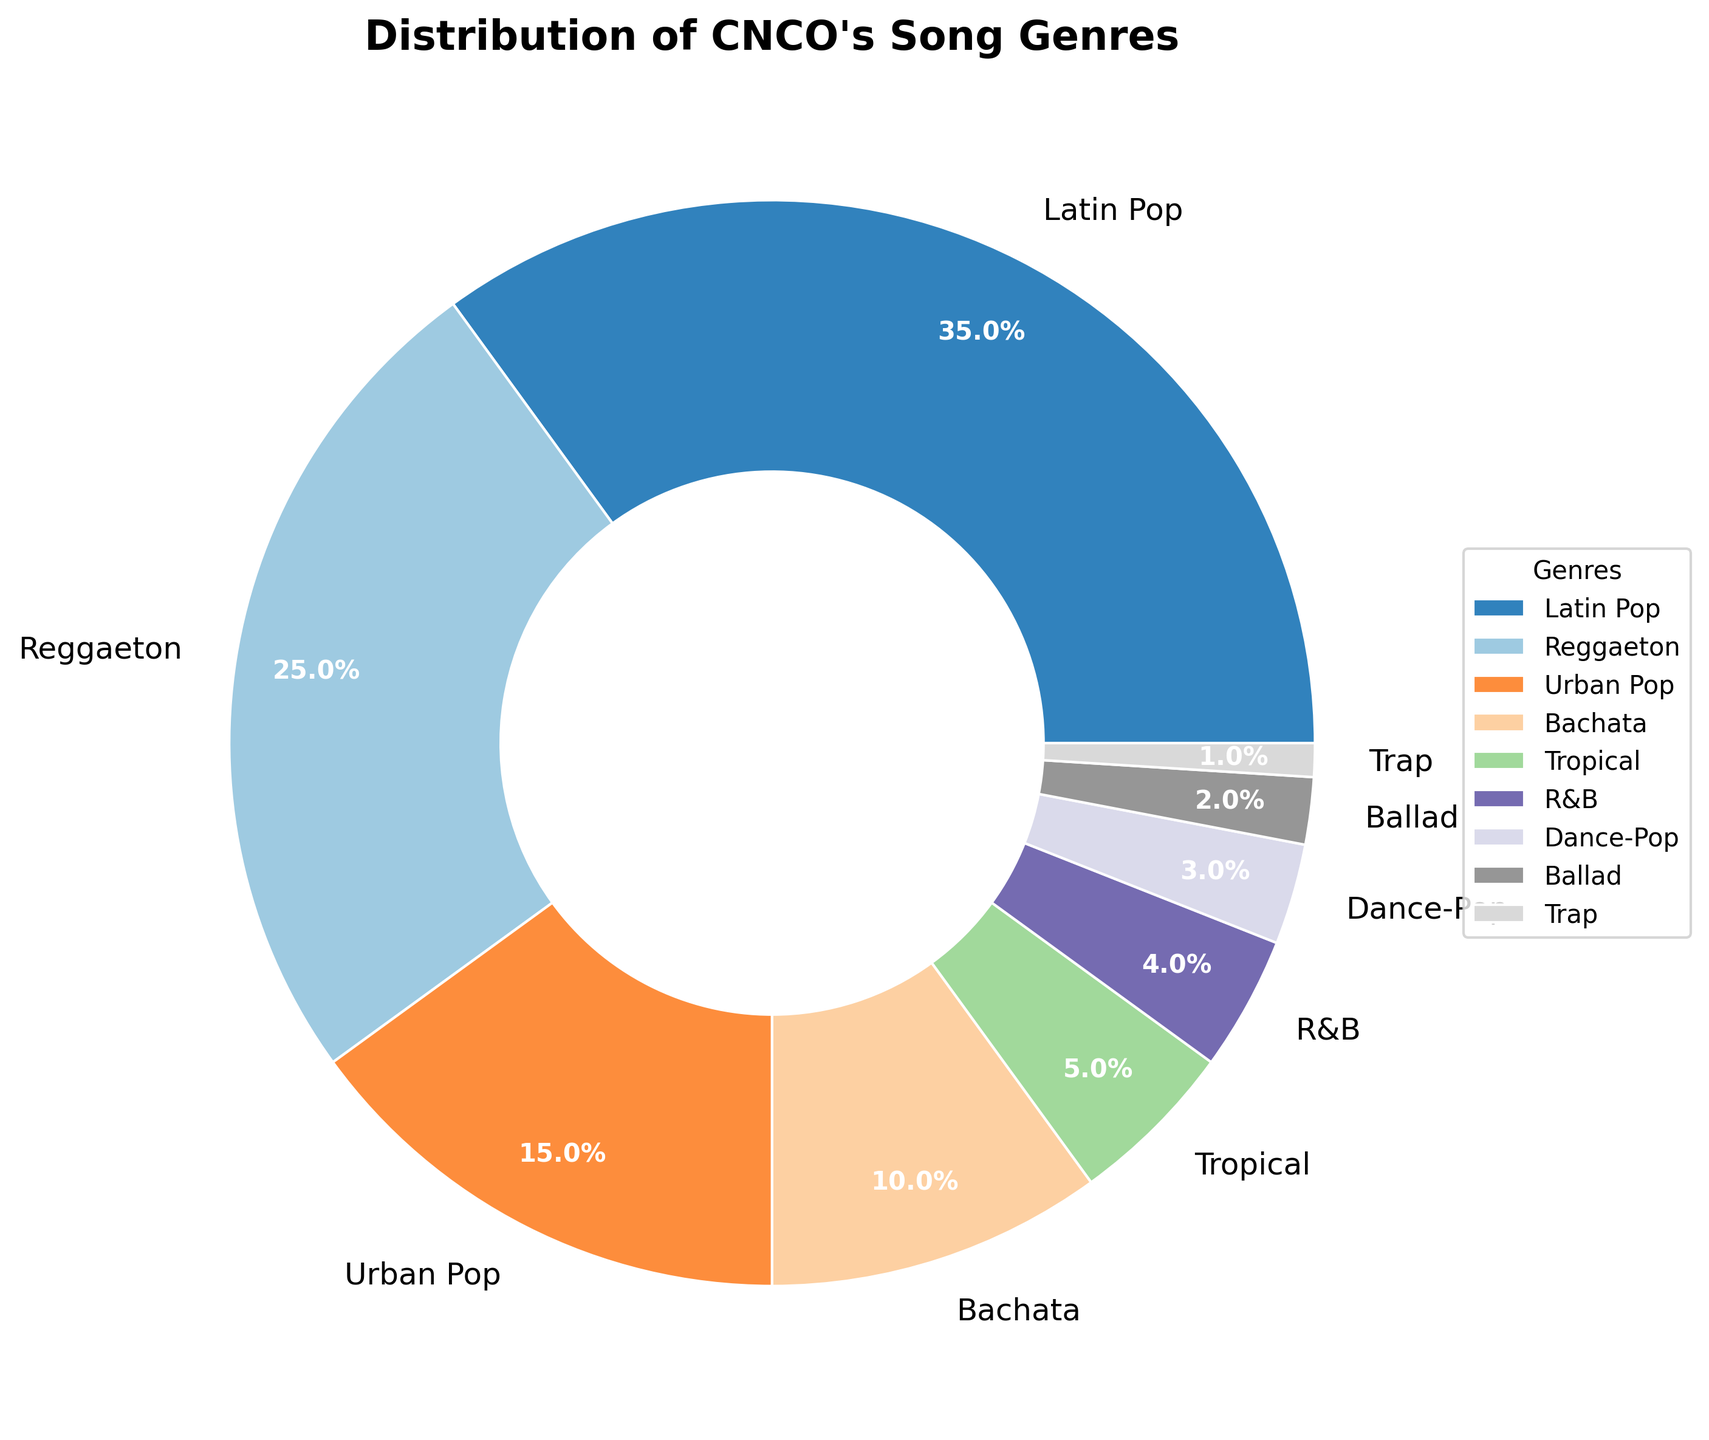Which genre has the highest percentage in CNCO's discography? By looking at the pie chart, find the genre with the largest slice. The genre with the highest percentage is Latin Pop at 35%.
Answer: Latin Pop Which genres have a smaller percentage than Urban Pop? Identify the percentage for Urban Pop, which is 15%. Then, compare this to the other genres. The genres with smaller percentages are Bachata (10%), Tropical (5%), R&B (4%), Dance-Pop (3%), Ballad (2%), and Trap (1%).
Answer: Bachata, Tropical, R&B, Dance-Pop, Ballad, Trap How do the percentages of Reggaeton and Latin Pop compare? Find the percentages for Reggaeton and Latin Pop, which are 25% and 35% respectively. Latin Pop's percentage is greater than Reggaeton's by 10 percentage points.
Answer: Latin Pop has 10% more than Reggaeton What is the combined percentage of genres that are less than or equal to 10%? Add the percentages of genres that are ≤10%: Bachata (10%) + Tropical (5%) + R&B (4%) + Dance-Pop (3%) + Ballad (2%) + Trap (1%) = 25%.
Answer: 25% What percentage of CNCO's songs are either Urban Pop or Dance-Pop? Add the percentages for Urban Pop (15%) and Dance-Pop (3%): 15% + 3% = 18%.
Answer: 18% Which genre represents the smallest percentage of CNCO's discography? Identify the genre with the smallest slice in the pie chart, which is Trap at 1%.
Answer: Trap Is the percentage of Bachata songs greater or less than the percentage of Tropical songs? Compare the percentages: Bachata is 10%, Tropical is 5%. Bachata has a higher percentage than Tropical.
Answer: Greater What’s the difference between the percentages of Latin Pop and Urban Pop genres? Subtract the percentage of Urban Pop (15%) from that of Latin Pop (35%): 35% - 15% = 20%.
Answer: 20% How many genres have a percentage of 5% or less? Count the genres that have 5% or less from the data: Tropical (5%), R&B (4%), Dance-Pop (3%), Ballad (2%), and Trap (1%) which are 5 genres.
Answer: 5 What's the combined percentage of the top three most common genres in CNCO's discography? Sum the percentages of the top three genres: Latin Pop (35%) + Reggaeton (25%) + Urban Pop (15%) = 75%.
Answer: 75% 